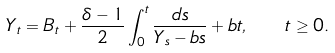<formula> <loc_0><loc_0><loc_500><loc_500>Y _ { t } = B _ { t } + \frac { \delta - 1 } { 2 } \int _ { 0 } ^ { t } \frac { d s } { Y _ { s } - b s } + b t , \quad t \geq 0 .</formula> 